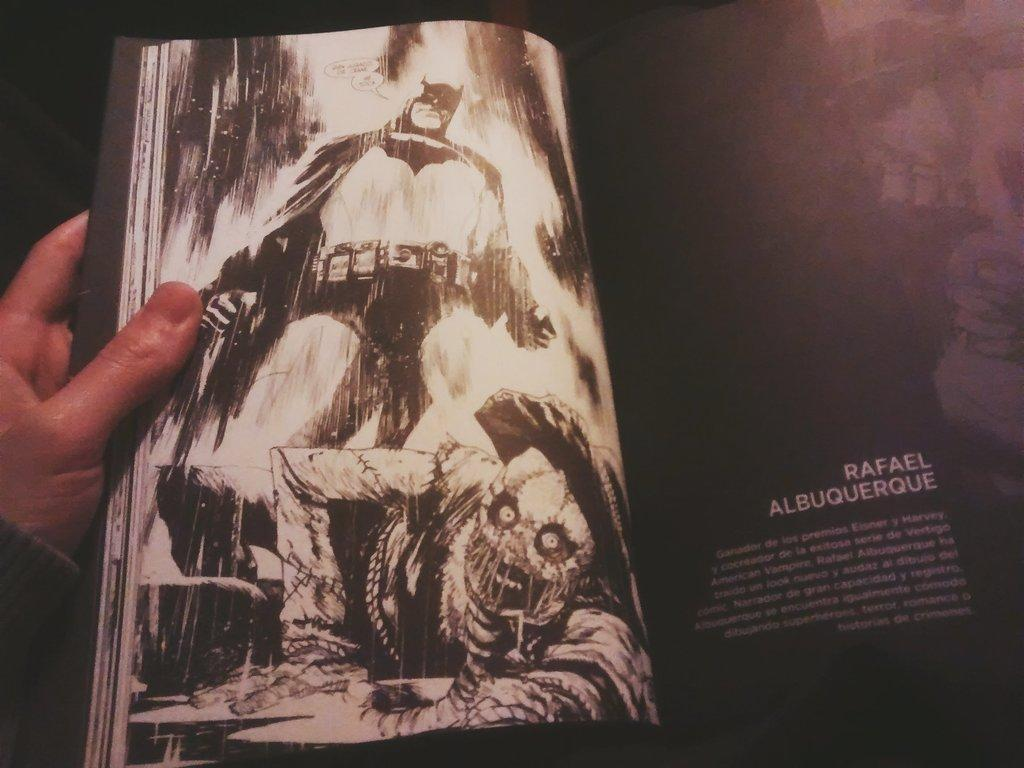Who or what is present in the image? There is a person in the image. What is the person holding in their hand? The person is holding a book in their hand. What else can be seen in the image besides the person and the book? There are papers in the image. Can you describe the content of the papers? The papers contain a sketch of people and there is writing on them. What type of quartz can be seen in the person's hand in the image? There is no quartz present in the image; the person is holding a book. Can you tell me the account balance of the person in the image? There is no information about the person's account balance in the image. 